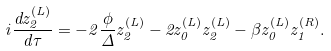Convert formula to latex. <formula><loc_0><loc_0><loc_500><loc_500>i \frac { d z ^ { ( L ) } _ { 2 } } { d \tau } = - 2 \frac { \phi } { \Delta } z ^ { ( L ) } _ { 2 } - 2 z ^ { ( L ) } _ { 0 } z ^ { ( L ) } _ { 2 } - \beta z ^ { ( L ) } _ { 0 } z ^ { ( R ) } _ { 1 } .</formula> 